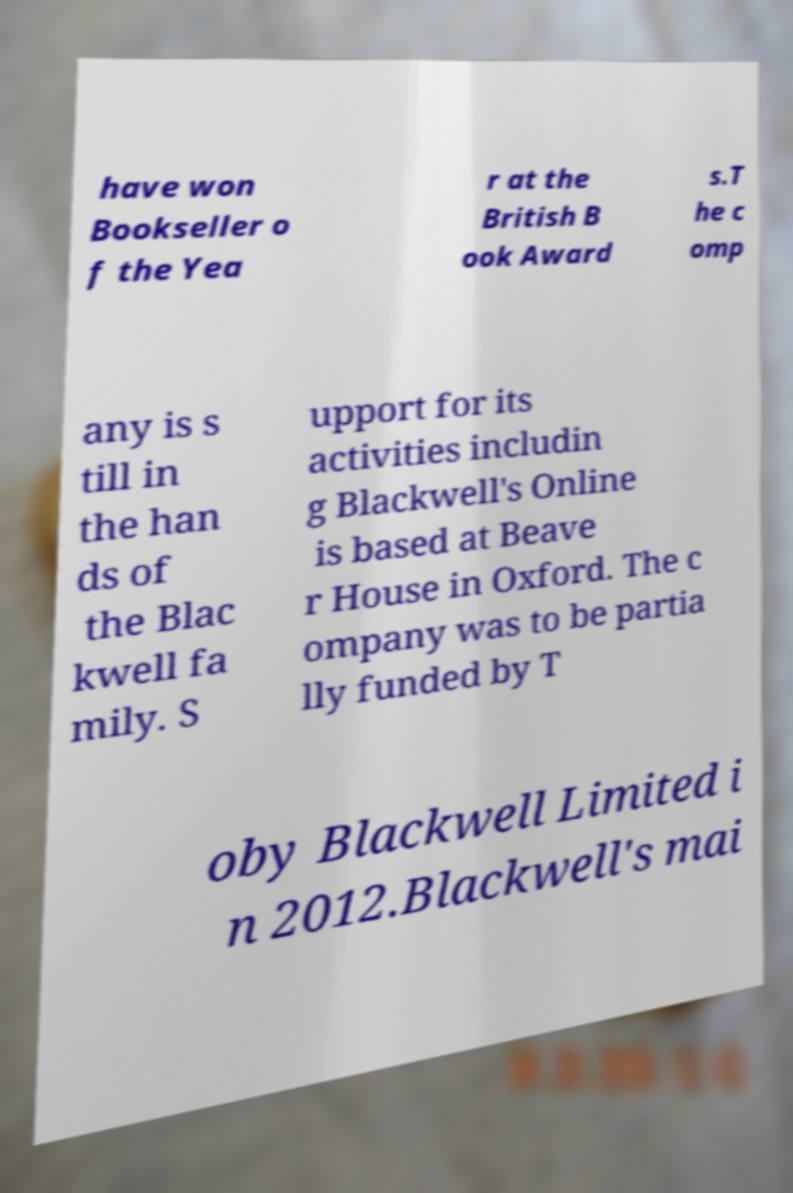There's text embedded in this image that I need extracted. Can you transcribe it verbatim? have won Bookseller o f the Yea r at the British B ook Award s.T he c omp any is s till in the han ds of the Blac kwell fa mily. S upport for its activities includin g Blackwell's Online is based at Beave r House in Oxford. The c ompany was to be partia lly funded by T oby Blackwell Limited i n 2012.Blackwell's mai 